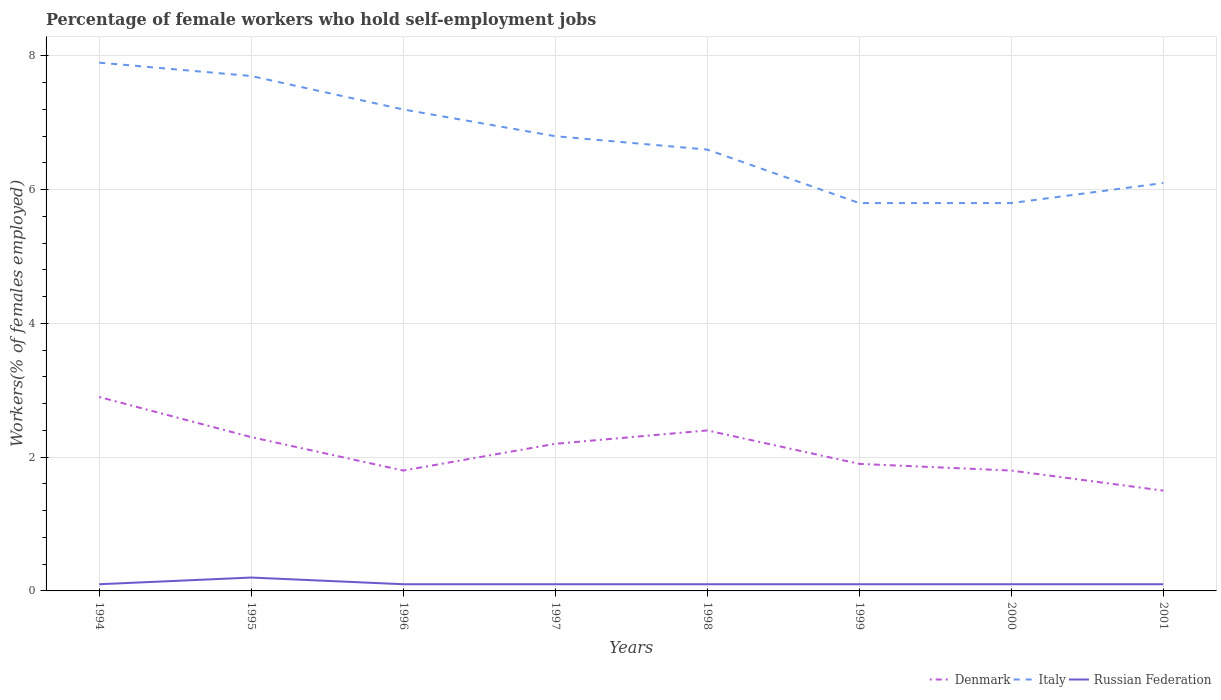How many different coloured lines are there?
Offer a very short reply. 3. Is the number of lines equal to the number of legend labels?
Your answer should be very brief. Yes. Across all years, what is the maximum percentage of self-employed female workers in Russian Federation?
Your answer should be compact. 0.1. In which year was the percentage of self-employed female workers in Denmark maximum?
Your answer should be compact. 2001. What is the total percentage of self-employed female workers in Italy in the graph?
Keep it short and to the point. 0.8. What is the difference between the highest and the second highest percentage of self-employed female workers in Russian Federation?
Your answer should be very brief. 0.1. How many lines are there?
Ensure brevity in your answer.  3. Does the graph contain grids?
Offer a very short reply. Yes. Where does the legend appear in the graph?
Ensure brevity in your answer.  Bottom right. How many legend labels are there?
Ensure brevity in your answer.  3. How are the legend labels stacked?
Your answer should be compact. Horizontal. What is the title of the graph?
Offer a very short reply. Percentage of female workers who hold self-employment jobs. What is the label or title of the Y-axis?
Offer a very short reply. Workers(% of females employed). What is the Workers(% of females employed) in Denmark in 1994?
Give a very brief answer. 2.9. What is the Workers(% of females employed) of Italy in 1994?
Your answer should be very brief. 7.9. What is the Workers(% of females employed) in Russian Federation in 1994?
Provide a short and direct response. 0.1. What is the Workers(% of females employed) in Denmark in 1995?
Offer a terse response. 2.3. What is the Workers(% of females employed) of Italy in 1995?
Offer a very short reply. 7.7. What is the Workers(% of females employed) of Russian Federation in 1995?
Offer a terse response. 0.2. What is the Workers(% of females employed) in Denmark in 1996?
Your answer should be very brief. 1.8. What is the Workers(% of females employed) of Italy in 1996?
Provide a short and direct response. 7.2. What is the Workers(% of females employed) in Russian Federation in 1996?
Your answer should be compact. 0.1. What is the Workers(% of females employed) of Denmark in 1997?
Provide a succinct answer. 2.2. What is the Workers(% of females employed) in Italy in 1997?
Keep it short and to the point. 6.8. What is the Workers(% of females employed) in Russian Federation in 1997?
Make the answer very short. 0.1. What is the Workers(% of females employed) of Denmark in 1998?
Your answer should be compact. 2.4. What is the Workers(% of females employed) of Italy in 1998?
Make the answer very short. 6.6. What is the Workers(% of females employed) in Russian Federation in 1998?
Make the answer very short. 0.1. What is the Workers(% of females employed) of Denmark in 1999?
Your response must be concise. 1.9. What is the Workers(% of females employed) in Italy in 1999?
Provide a short and direct response. 5.8. What is the Workers(% of females employed) in Russian Federation in 1999?
Keep it short and to the point. 0.1. What is the Workers(% of females employed) in Denmark in 2000?
Your answer should be very brief. 1.8. What is the Workers(% of females employed) of Italy in 2000?
Give a very brief answer. 5.8. What is the Workers(% of females employed) in Russian Federation in 2000?
Provide a short and direct response. 0.1. What is the Workers(% of females employed) of Denmark in 2001?
Provide a succinct answer. 1.5. What is the Workers(% of females employed) in Italy in 2001?
Your response must be concise. 6.1. What is the Workers(% of females employed) in Russian Federation in 2001?
Ensure brevity in your answer.  0.1. Across all years, what is the maximum Workers(% of females employed) in Denmark?
Your response must be concise. 2.9. Across all years, what is the maximum Workers(% of females employed) of Italy?
Make the answer very short. 7.9. Across all years, what is the maximum Workers(% of females employed) of Russian Federation?
Keep it short and to the point. 0.2. Across all years, what is the minimum Workers(% of females employed) in Italy?
Your response must be concise. 5.8. Across all years, what is the minimum Workers(% of females employed) in Russian Federation?
Offer a very short reply. 0.1. What is the total Workers(% of females employed) of Italy in the graph?
Provide a succinct answer. 53.9. What is the difference between the Workers(% of females employed) in Denmark in 1994 and that in 1995?
Give a very brief answer. 0.6. What is the difference between the Workers(% of females employed) in Italy in 1994 and that in 1995?
Your answer should be very brief. 0.2. What is the difference between the Workers(% of females employed) in Russian Federation in 1994 and that in 1995?
Provide a short and direct response. -0.1. What is the difference between the Workers(% of females employed) of Russian Federation in 1994 and that in 1996?
Ensure brevity in your answer.  0. What is the difference between the Workers(% of females employed) of Italy in 1994 and that in 1997?
Offer a terse response. 1.1. What is the difference between the Workers(% of females employed) in Italy in 1994 and that in 1998?
Offer a terse response. 1.3. What is the difference between the Workers(% of females employed) in Denmark in 1994 and that in 1999?
Provide a short and direct response. 1. What is the difference between the Workers(% of females employed) in Italy in 1994 and that in 1999?
Offer a terse response. 2.1. What is the difference between the Workers(% of females employed) of Russian Federation in 1994 and that in 1999?
Your answer should be compact. 0. What is the difference between the Workers(% of females employed) of Denmark in 1994 and that in 2000?
Make the answer very short. 1.1. What is the difference between the Workers(% of females employed) in Russian Federation in 1994 and that in 2000?
Provide a succinct answer. 0. What is the difference between the Workers(% of females employed) in Russian Federation in 1994 and that in 2001?
Ensure brevity in your answer.  0. What is the difference between the Workers(% of females employed) in Denmark in 1995 and that in 1996?
Your answer should be compact. 0.5. What is the difference between the Workers(% of females employed) in Russian Federation in 1995 and that in 1996?
Your answer should be very brief. 0.1. What is the difference between the Workers(% of females employed) in Denmark in 1995 and that in 1997?
Offer a terse response. 0.1. What is the difference between the Workers(% of females employed) of Denmark in 1995 and that in 1998?
Offer a very short reply. -0.1. What is the difference between the Workers(% of females employed) of Italy in 1995 and that in 1998?
Offer a very short reply. 1.1. What is the difference between the Workers(% of females employed) of Russian Federation in 1995 and that in 1998?
Keep it short and to the point. 0.1. What is the difference between the Workers(% of females employed) in Denmark in 1995 and that in 1999?
Offer a terse response. 0.4. What is the difference between the Workers(% of females employed) in Italy in 1995 and that in 1999?
Give a very brief answer. 1.9. What is the difference between the Workers(% of females employed) in Russian Federation in 1995 and that in 1999?
Keep it short and to the point. 0.1. What is the difference between the Workers(% of females employed) of Denmark in 1995 and that in 2000?
Keep it short and to the point. 0.5. What is the difference between the Workers(% of females employed) in Russian Federation in 1995 and that in 2000?
Give a very brief answer. 0.1. What is the difference between the Workers(% of females employed) in Denmark in 1995 and that in 2001?
Your answer should be compact. 0.8. What is the difference between the Workers(% of females employed) of Italy in 1995 and that in 2001?
Keep it short and to the point. 1.6. What is the difference between the Workers(% of females employed) of Russian Federation in 1995 and that in 2001?
Make the answer very short. 0.1. What is the difference between the Workers(% of females employed) of Russian Federation in 1996 and that in 1997?
Give a very brief answer. 0. What is the difference between the Workers(% of females employed) in Denmark in 1996 and that in 1998?
Offer a terse response. -0.6. What is the difference between the Workers(% of females employed) in Denmark in 1996 and that in 1999?
Provide a short and direct response. -0.1. What is the difference between the Workers(% of females employed) in Russian Federation in 1996 and that in 1999?
Ensure brevity in your answer.  0. What is the difference between the Workers(% of females employed) of Denmark in 1996 and that in 2000?
Your response must be concise. 0. What is the difference between the Workers(% of females employed) of Italy in 1996 and that in 2000?
Give a very brief answer. 1.4. What is the difference between the Workers(% of females employed) of Denmark in 1996 and that in 2001?
Your response must be concise. 0.3. What is the difference between the Workers(% of females employed) in Denmark in 1997 and that in 1999?
Ensure brevity in your answer.  0.3. What is the difference between the Workers(% of females employed) in Russian Federation in 1997 and that in 1999?
Provide a succinct answer. 0. What is the difference between the Workers(% of females employed) in Italy in 1997 and that in 2000?
Your answer should be very brief. 1. What is the difference between the Workers(% of females employed) of Russian Federation in 1997 and that in 2000?
Keep it short and to the point. 0. What is the difference between the Workers(% of females employed) of Denmark in 1997 and that in 2001?
Give a very brief answer. 0.7. What is the difference between the Workers(% of females employed) of Italy in 1997 and that in 2001?
Offer a terse response. 0.7. What is the difference between the Workers(% of females employed) in Russian Federation in 1997 and that in 2001?
Your answer should be very brief. 0. What is the difference between the Workers(% of females employed) of Denmark in 1998 and that in 1999?
Give a very brief answer. 0.5. What is the difference between the Workers(% of females employed) of Russian Federation in 1998 and that in 1999?
Your answer should be very brief. 0. What is the difference between the Workers(% of females employed) of Denmark in 1998 and that in 2000?
Your answer should be compact. 0.6. What is the difference between the Workers(% of females employed) of Russian Federation in 1998 and that in 2000?
Your answer should be compact. 0. What is the difference between the Workers(% of females employed) of Denmark in 1998 and that in 2001?
Ensure brevity in your answer.  0.9. What is the difference between the Workers(% of females employed) of Russian Federation in 1998 and that in 2001?
Keep it short and to the point. 0. What is the difference between the Workers(% of females employed) of Denmark in 1999 and that in 2000?
Offer a terse response. 0.1. What is the difference between the Workers(% of females employed) in Italy in 1999 and that in 2000?
Offer a terse response. 0. What is the difference between the Workers(% of females employed) of Russian Federation in 1999 and that in 2000?
Your response must be concise. 0. What is the difference between the Workers(% of females employed) in Denmark in 1999 and that in 2001?
Offer a very short reply. 0.4. What is the difference between the Workers(% of females employed) of Denmark in 2000 and that in 2001?
Offer a very short reply. 0.3. What is the difference between the Workers(% of females employed) of Denmark in 1994 and the Workers(% of females employed) of Russian Federation in 1995?
Offer a very short reply. 2.7. What is the difference between the Workers(% of females employed) in Denmark in 1994 and the Workers(% of females employed) in Russian Federation in 1996?
Keep it short and to the point. 2.8. What is the difference between the Workers(% of females employed) in Denmark in 1994 and the Workers(% of females employed) in Italy in 1997?
Provide a short and direct response. -3.9. What is the difference between the Workers(% of females employed) of Denmark in 1994 and the Workers(% of females employed) of Russian Federation in 1997?
Ensure brevity in your answer.  2.8. What is the difference between the Workers(% of females employed) in Italy in 1994 and the Workers(% of females employed) in Russian Federation in 1997?
Give a very brief answer. 7.8. What is the difference between the Workers(% of females employed) in Italy in 1994 and the Workers(% of females employed) in Russian Federation in 1998?
Your response must be concise. 7.8. What is the difference between the Workers(% of females employed) in Denmark in 1994 and the Workers(% of females employed) in Italy in 1999?
Make the answer very short. -2.9. What is the difference between the Workers(% of females employed) of Denmark in 1994 and the Workers(% of females employed) of Russian Federation in 1999?
Give a very brief answer. 2.8. What is the difference between the Workers(% of females employed) in Denmark in 1994 and the Workers(% of females employed) in Italy in 2000?
Make the answer very short. -2.9. What is the difference between the Workers(% of females employed) in Denmark in 1994 and the Workers(% of females employed) in Italy in 2001?
Provide a succinct answer. -3.2. What is the difference between the Workers(% of females employed) in Italy in 1994 and the Workers(% of females employed) in Russian Federation in 2001?
Your answer should be compact. 7.8. What is the difference between the Workers(% of females employed) of Italy in 1995 and the Workers(% of females employed) of Russian Federation in 1996?
Ensure brevity in your answer.  7.6. What is the difference between the Workers(% of females employed) of Denmark in 1995 and the Workers(% of females employed) of Russian Federation in 1997?
Your answer should be compact. 2.2. What is the difference between the Workers(% of females employed) in Italy in 1995 and the Workers(% of females employed) in Russian Federation in 1997?
Ensure brevity in your answer.  7.6. What is the difference between the Workers(% of females employed) of Denmark in 1995 and the Workers(% of females employed) of Italy in 1998?
Your answer should be compact. -4.3. What is the difference between the Workers(% of females employed) of Denmark in 1995 and the Workers(% of females employed) of Russian Federation in 1999?
Make the answer very short. 2.2. What is the difference between the Workers(% of females employed) in Italy in 1995 and the Workers(% of females employed) in Russian Federation in 1999?
Provide a short and direct response. 7.6. What is the difference between the Workers(% of females employed) of Denmark in 1995 and the Workers(% of females employed) of Italy in 2000?
Offer a terse response. -3.5. What is the difference between the Workers(% of females employed) of Italy in 1995 and the Workers(% of females employed) of Russian Federation in 2001?
Give a very brief answer. 7.6. What is the difference between the Workers(% of females employed) of Italy in 1996 and the Workers(% of females employed) of Russian Federation in 1997?
Your answer should be compact. 7.1. What is the difference between the Workers(% of females employed) in Denmark in 1996 and the Workers(% of females employed) in Russian Federation in 1998?
Offer a very short reply. 1.7. What is the difference between the Workers(% of females employed) in Italy in 1996 and the Workers(% of females employed) in Russian Federation in 1998?
Make the answer very short. 7.1. What is the difference between the Workers(% of females employed) of Denmark in 1996 and the Workers(% of females employed) of Italy in 1999?
Your response must be concise. -4. What is the difference between the Workers(% of females employed) in Italy in 1996 and the Workers(% of females employed) in Russian Federation in 1999?
Ensure brevity in your answer.  7.1. What is the difference between the Workers(% of females employed) in Italy in 1996 and the Workers(% of females employed) in Russian Federation in 2000?
Your response must be concise. 7.1. What is the difference between the Workers(% of females employed) in Denmark in 1996 and the Workers(% of females employed) in Italy in 2001?
Provide a succinct answer. -4.3. What is the difference between the Workers(% of females employed) in Italy in 1996 and the Workers(% of females employed) in Russian Federation in 2001?
Your response must be concise. 7.1. What is the difference between the Workers(% of females employed) of Denmark in 1997 and the Workers(% of females employed) of Russian Federation in 1998?
Your answer should be compact. 2.1. What is the difference between the Workers(% of females employed) of Denmark in 1997 and the Workers(% of females employed) of Russian Federation in 1999?
Your response must be concise. 2.1. What is the difference between the Workers(% of females employed) of Italy in 1997 and the Workers(% of females employed) of Russian Federation in 1999?
Ensure brevity in your answer.  6.7. What is the difference between the Workers(% of females employed) of Denmark in 1997 and the Workers(% of females employed) of Italy in 2000?
Provide a short and direct response. -3.6. What is the difference between the Workers(% of females employed) in Denmark in 1998 and the Workers(% of females employed) in Italy in 1999?
Provide a succinct answer. -3.4. What is the difference between the Workers(% of females employed) in Italy in 1998 and the Workers(% of females employed) in Russian Federation in 2000?
Your answer should be very brief. 6.5. What is the difference between the Workers(% of females employed) in Denmark in 1998 and the Workers(% of females employed) in Italy in 2001?
Offer a terse response. -3.7. What is the difference between the Workers(% of females employed) of Italy in 1998 and the Workers(% of females employed) of Russian Federation in 2001?
Your response must be concise. 6.5. What is the difference between the Workers(% of females employed) in Denmark in 1999 and the Workers(% of females employed) in Italy in 2001?
Your response must be concise. -4.2. What is the difference between the Workers(% of females employed) in Italy in 2000 and the Workers(% of females employed) in Russian Federation in 2001?
Make the answer very short. 5.7. What is the average Workers(% of females employed) of Italy per year?
Offer a very short reply. 6.74. What is the average Workers(% of females employed) of Russian Federation per year?
Offer a terse response. 0.11. In the year 1994, what is the difference between the Workers(% of females employed) of Denmark and Workers(% of females employed) of Russian Federation?
Offer a terse response. 2.8. In the year 1994, what is the difference between the Workers(% of females employed) of Italy and Workers(% of females employed) of Russian Federation?
Provide a short and direct response. 7.8. In the year 1995, what is the difference between the Workers(% of females employed) in Denmark and Workers(% of females employed) in Italy?
Provide a short and direct response. -5.4. In the year 1995, what is the difference between the Workers(% of females employed) in Denmark and Workers(% of females employed) in Russian Federation?
Keep it short and to the point. 2.1. In the year 1995, what is the difference between the Workers(% of females employed) in Italy and Workers(% of females employed) in Russian Federation?
Ensure brevity in your answer.  7.5. In the year 1996, what is the difference between the Workers(% of females employed) of Denmark and Workers(% of females employed) of Italy?
Offer a terse response. -5.4. In the year 1996, what is the difference between the Workers(% of females employed) of Denmark and Workers(% of females employed) of Russian Federation?
Give a very brief answer. 1.7. In the year 1996, what is the difference between the Workers(% of females employed) in Italy and Workers(% of females employed) in Russian Federation?
Offer a terse response. 7.1. In the year 1997, what is the difference between the Workers(% of females employed) in Denmark and Workers(% of females employed) in Russian Federation?
Provide a short and direct response. 2.1. In the year 1997, what is the difference between the Workers(% of females employed) in Italy and Workers(% of females employed) in Russian Federation?
Offer a terse response. 6.7. In the year 2000, what is the difference between the Workers(% of females employed) of Denmark and Workers(% of females employed) of Italy?
Your answer should be very brief. -4. In the year 2000, what is the difference between the Workers(% of females employed) of Denmark and Workers(% of females employed) of Russian Federation?
Provide a succinct answer. 1.7. In the year 2001, what is the difference between the Workers(% of females employed) of Italy and Workers(% of females employed) of Russian Federation?
Your answer should be compact. 6. What is the ratio of the Workers(% of females employed) of Denmark in 1994 to that in 1995?
Provide a short and direct response. 1.26. What is the ratio of the Workers(% of females employed) in Russian Federation in 1994 to that in 1995?
Your answer should be compact. 0.5. What is the ratio of the Workers(% of females employed) of Denmark in 1994 to that in 1996?
Provide a short and direct response. 1.61. What is the ratio of the Workers(% of females employed) of Italy in 1994 to that in 1996?
Give a very brief answer. 1.1. What is the ratio of the Workers(% of females employed) of Russian Federation in 1994 to that in 1996?
Offer a terse response. 1. What is the ratio of the Workers(% of females employed) in Denmark in 1994 to that in 1997?
Keep it short and to the point. 1.32. What is the ratio of the Workers(% of females employed) in Italy in 1994 to that in 1997?
Your response must be concise. 1.16. What is the ratio of the Workers(% of females employed) of Russian Federation in 1994 to that in 1997?
Give a very brief answer. 1. What is the ratio of the Workers(% of females employed) of Denmark in 1994 to that in 1998?
Provide a succinct answer. 1.21. What is the ratio of the Workers(% of females employed) in Italy in 1994 to that in 1998?
Provide a short and direct response. 1.2. What is the ratio of the Workers(% of females employed) of Denmark in 1994 to that in 1999?
Provide a short and direct response. 1.53. What is the ratio of the Workers(% of females employed) in Italy in 1994 to that in 1999?
Give a very brief answer. 1.36. What is the ratio of the Workers(% of females employed) of Denmark in 1994 to that in 2000?
Make the answer very short. 1.61. What is the ratio of the Workers(% of females employed) in Italy in 1994 to that in 2000?
Provide a short and direct response. 1.36. What is the ratio of the Workers(% of females employed) of Russian Federation in 1994 to that in 2000?
Your answer should be very brief. 1. What is the ratio of the Workers(% of females employed) of Denmark in 1994 to that in 2001?
Provide a short and direct response. 1.93. What is the ratio of the Workers(% of females employed) of Italy in 1994 to that in 2001?
Offer a terse response. 1.3. What is the ratio of the Workers(% of females employed) of Russian Federation in 1994 to that in 2001?
Offer a very short reply. 1. What is the ratio of the Workers(% of females employed) of Denmark in 1995 to that in 1996?
Provide a short and direct response. 1.28. What is the ratio of the Workers(% of females employed) in Italy in 1995 to that in 1996?
Your response must be concise. 1.07. What is the ratio of the Workers(% of females employed) in Denmark in 1995 to that in 1997?
Your response must be concise. 1.05. What is the ratio of the Workers(% of females employed) of Italy in 1995 to that in 1997?
Ensure brevity in your answer.  1.13. What is the ratio of the Workers(% of females employed) of Russian Federation in 1995 to that in 1997?
Your response must be concise. 2. What is the ratio of the Workers(% of females employed) of Denmark in 1995 to that in 1998?
Make the answer very short. 0.96. What is the ratio of the Workers(% of females employed) in Denmark in 1995 to that in 1999?
Provide a succinct answer. 1.21. What is the ratio of the Workers(% of females employed) of Italy in 1995 to that in 1999?
Keep it short and to the point. 1.33. What is the ratio of the Workers(% of females employed) in Russian Federation in 1995 to that in 1999?
Your answer should be compact. 2. What is the ratio of the Workers(% of females employed) in Denmark in 1995 to that in 2000?
Keep it short and to the point. 1.28. What is the ratio of the Workers(% of females employed) of Italy in 1995 to that in 2000?
Provide a short and direct response. 1.33. What is the ratio of the Workers(% of females employed) of Russian Federation in 1995 to that in 2000?
Your answer should be compact. 2. What is the ratio of the Workers(% of females employed) of Denmark in 1995 to that in 2001?
Offer a terse response. 1.53. What is the ratio of the Workers(% of females employed) in Italy in 1995 to that in 2001?
Your answer should be very brief. 1.26. What is the ratio of the Workers(% of females employed) in Denmark in 1996 to that in 1997?
Make the answer very short. 0.82. What is the ratio of the Workers(% of females employed) in Italy in 1996 to that in 1997?
Offer a very short reply. 1.06. What is the ratio of the Workers(% of females employed) of Denmark in 1996 to that in 1998?
Your response must be concise. 0.75. What is the ratio of the Workers(% of females employed) of Italy in 1996 to that in 1998?
Give a very brief answer. 1.09. What is the ratio of the Workers(% of females employed) in Russian Federation in 1996 to that in 1998?
Ensure brevity in your answer.  1. What is the ratio of the Workers(% of females employed) in Italy in 1996 to that in 1999?
Make the answer very short. 1.24. What is the ratio of the Workers(% of females employed) of Russian Federation in 1996 to that in 1999?
Your response must be concise. 1. What is the ratio of the Workers(% of females employed) in Denmark in 1996 to that in 2000?
Offer a very short reply. 1. What is the ratio of the Workers(% of females employed) in Italy in 1996 to that in 2000?
Ensure brevity in your answer.  1.24. What is the ratio of the Workers(% of females employed) of Italy in 1996 to that in 2001?
Keep it short and to the point. 1.18. What is the ratio of the Workers(% of females employed) in Russian Federation in 1996 to that in 2001?
Provide a succinct answer. 1. What is the ratio of the Workers(% of females employed) in Denmark in 1997 to that in 1998?
Provide a succinct answer. 0.92. What is the ratio of the Workers(% of females employed) of Italy in 1997 to that in 1998?
Your answer should be compact. 1.03. What is the ratio of the Workers(% of females employed) of Denmark in 1997 to that in 1999?
Provide a short and direct response. 1.16. What is the ratio of the Workers(% of females employed) in Italy in 1997 to that in 1999?
Offer a terse response. 1.17. What is the ratio of the Workers(% of females employed) of Denmark in 1997 to that in 2000?
Your answer should be compact. 1.22. What is the ratio of the Workers(% of females employed) of Italy in 1997 to that in 2000?
Your answer should be very brief. 1.17. What is the ratio of the Workers(% of females employed) of Denmark in 1997 to that in 2001?
Your answer should be compact. 1.47. What is the ratio of the Workers(% of females employed) in Italy in 1997 to that in 2001?
Your answer should be very brief. 1.11. What is the ratio of the Workers(% of females employed) in Russian Federation in 1997 to that in 2001?
Offer a very short reply. 1. What is the ratio of the Workers(% of females employed) of Denmark in 1998 to that in 1999?
Make the answer very short. 1.26. What is the ratio of the Workers(% of females employed) in Italy in 1998 to that in 1999?
Keep it short and to the point. 1.14. What is the ratio of the Workers(% of females employed) of Italy in 1998 to that in 2000?
Provide a succinct answer. 1.14. What is the ratio of the Workers(% of females employed) in Denmark in 1998 to that in 2001?
Offer a very short reply. 1.6. What is the ratio of the Workers(% of females employed) in Italy in 1998 to that in 2001?
Your answer should be compact. 1.08. What is the ratio of the Workers(% of females employed) in Denmark in 1999 to that in 2000?
Provide a short and direct response. 1.06. What is the ratio of the Workers(% of females employed) of Denmark in 1999 to that in 2001?
Your response must be concise. 1.27. What is the ratio of the Workers(% of females employed) in Italy in 1999 to that in 2001?
Your answer should be very brief. 0.95. What is the ratio of the Workers(% of females employed) in Russian Federation in 1999 to that in 2001?
Keep it short and to the point. 1. What is the ratio of the Workers(% of females employed) in Denmark in 2000 to that in 2001?
Make the answer very short. 1.2. What is the ratio of the Workers(% of females employed) in Italy in 2000 to that in 2001?
Ensure brevity in your answer.  0.95. What is the ratio of the Workers(% of females employed) of Russian Federation in 2000 to that in 2001?
Offer a very short reply. 1. What is the difference between the highest and the second highest Workers(% of females employed) of Italy?
Provide a succinct answer. 0.2. What is the difference between the highest and the lowest Workers(% of females employed) in Denmark?
Ensure brevity in your answer.  1.4. What is the difference between the highest and the lowest Workers(% of females employed) in Italy?
Your answer should be compact. 2.1. 